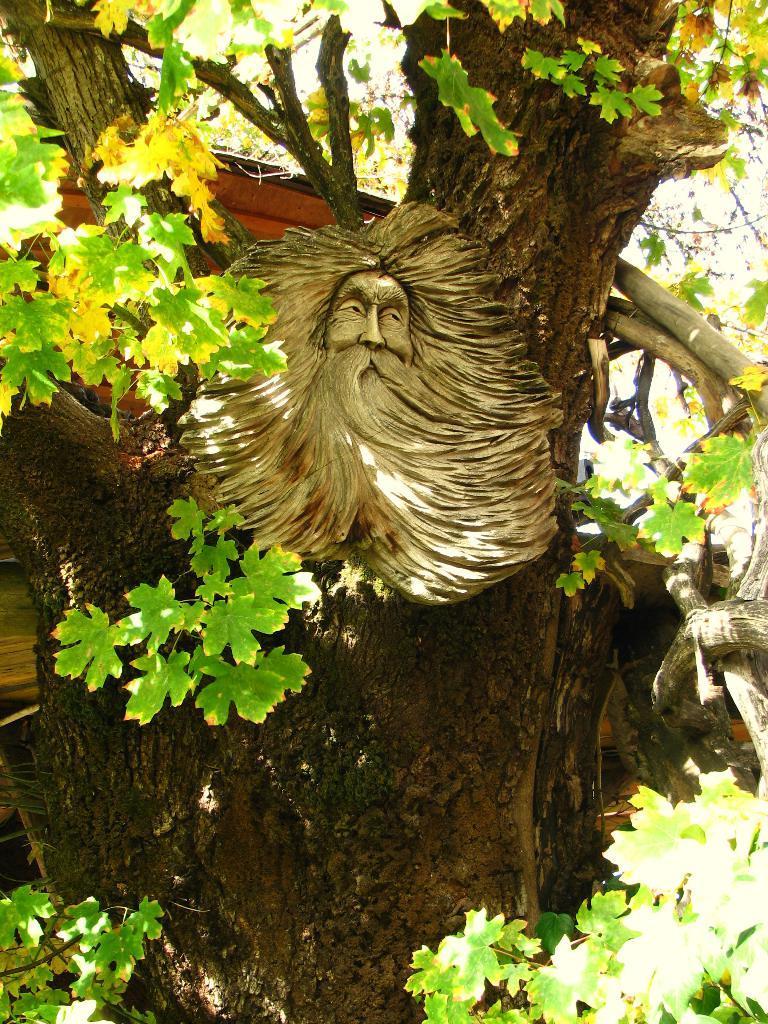Describe this image in one or two sentences. In this image, I can see the sculpture of a person's face. This looks like a tree trunk. I can see a tree with branches and leaves. 